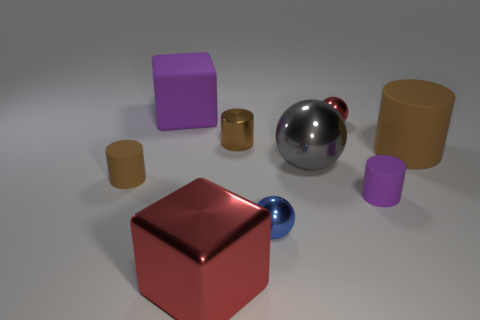What number of metallic spheres have the same color as the shiny block?
Your answer should be very brief. 1. What is the color of the small thing on the left side of the large object in front of the tiny matte thing that is on the right side of the big gray shiny object?
Your response must be concise. Brown. Does the big brown cylinder have the same material as the large purple cube?
Your answer should be very brief. Yes. Does the big purple object have the same shape as the big red metal object?
Your response must be concise. Yes. Is the number of matte things on the right side of the gray thing the same as the number of small balls that are behind the big red block?
Keep it short and to the point. Yes. There is a cube that is the same material as the big cylinder; what color is it?
Provide a succinct answer. Purple. What number of blue things are the same material as the large gray ball?
Ensure brevity in your answer.  1. Does the cylinder that is on the left side of the metal block have the same color as the big cylinder?
Make the answer very short. Yes. What number of small shiny objects have the same shape as the big brown matte thing?
Offer a very short reply. 1. Is the number of big red things in front of the tiny brown metal cylinder the same as the number of small red objects?
Your response must be concise. Yes. 